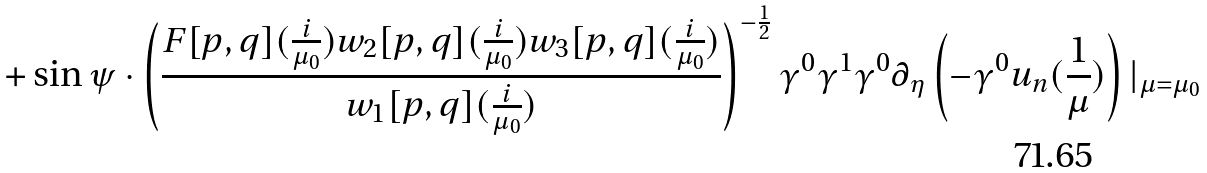Convert formula to latex. <formula><loc_0><loc_0><loc_500><loc_500>+ \sin \psi \cdot \left ( \frac { F [ p , q ] ( \frac { i } { \mu _ { 0 } } ) w _ { 2 } [ p , q ] ( \frac { i } { \mu _ { 0 } } ) w _ { 3 } [ p , q ] ( \frac { i } { \mu _ { 0 } } ) } { w _ { 1 } [ p , q ] ( \frac { i } { \mu _ { 0 } } ) } \right ) ^ { - \frac { 1 } { 2 } } \gamma ^ { 0 } \gamma ^ { 1 } \gamma ^ { 0 } \partial _ { \eta } \left ( - \gamma ^ { 0 } u _ { n } ( \frac { 1 } { \mu } ) \right ) | _ { \mu = \mu _ { 0 } }</formula> 